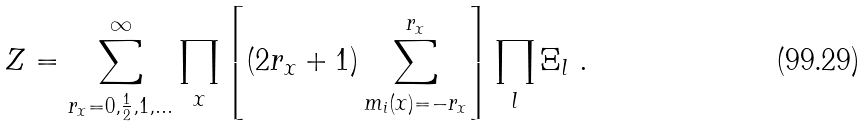<formula> <loc_0><loc_0><loc_500><loc_500>Z = \sum _ { r _ { x } = 0 , \frac { 1 } { 2 } , 1 , \dots } ^ { \infty } \prod _ { x } \left [ ( 2 r _ { x } + 1 ) \sum _ { m _ { i } ( x ) = - r _ { x } } ^ { r _ { x } } \right ] \prod _ { l } \Xi _ { l } \ .</formula> 